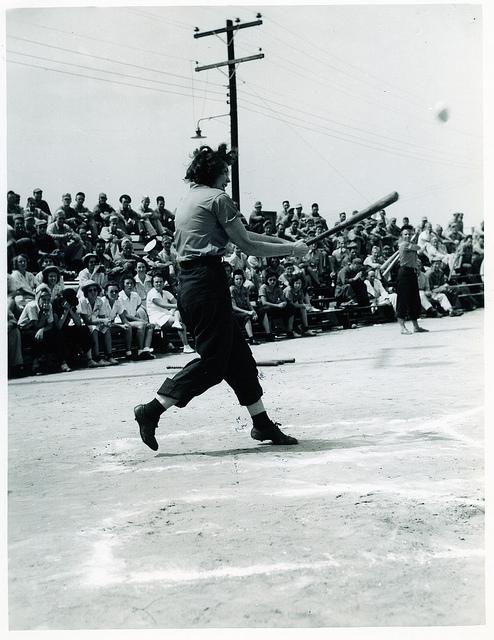How can you tell the photo is from long ago?
Quick response, please. Clothing. Is it snowing?
Answer briefly. No. Is there a crowd watching?
Concise answer only. Yes. What kind of pole is in the back?
Keep it brief. Power. Is this place cold?
Concise answer only. No. 